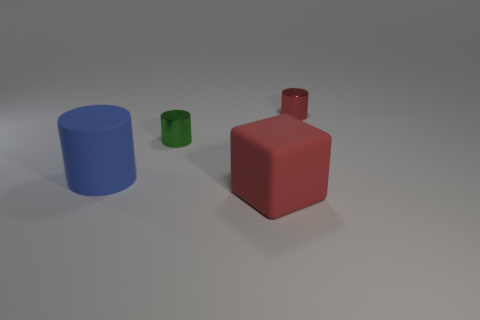Add 4 tiny gray matte cylinders. How many objects exist? 8 Subtract all blocks. How many objects are left? 3 Add 2 tiny red metallic objects. How many tiny red metallic objects are left? 3 Add 2 green things. How many green things exist? 3 Subtract 0 yellow cubes. How many objects are left? 4 Subtract all tiny red metal things. Subtract all red rubber objects. How many objects are left? 2 